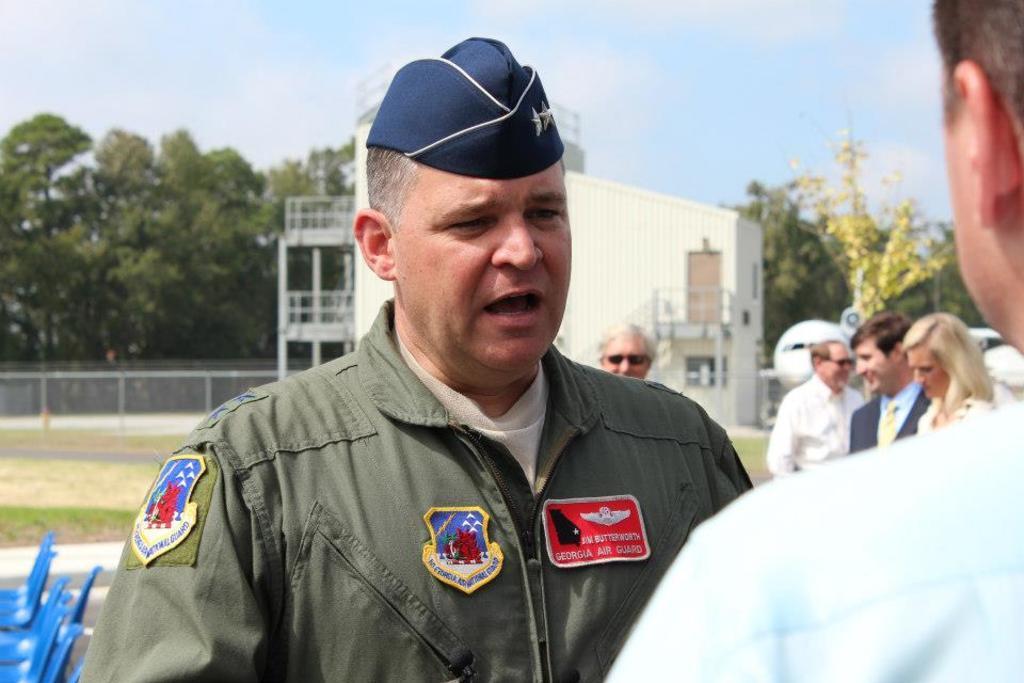What type of person can be seen in the image? There is an officer in the image. What are the people in the image doing? The people are standing together in the image. What can be seen in the background of the image? There is a building and trees in the background of the image. What type of straw is being used by the officer in the image? There is no straw present in the image. How many rolls of fabric can be seen on the ground in the image? There are no rolls of fabric present in the image. 